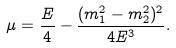<formula> <loc_0><loc_0><loc_500><loc_500>\mu = \frac { E } { 4 } - \frac { ( m _ { 1 } ^ { 2 } - m _ { 2 } ^ { 2 } ) ^ { 2 } } { 4 E ^ { 3 } } .</formula> 